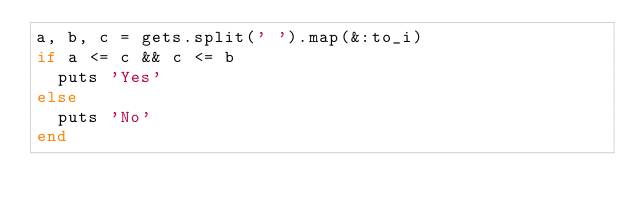Convert code to text. <code><loc_0><loc_0><loc_500><loc_500><_Ruby_>a, b, c = gets.split(' ').map(&:to_i)
if a <= c && c <= b
  puts 'Yes'
else
  puts 'No'
end
</code> 